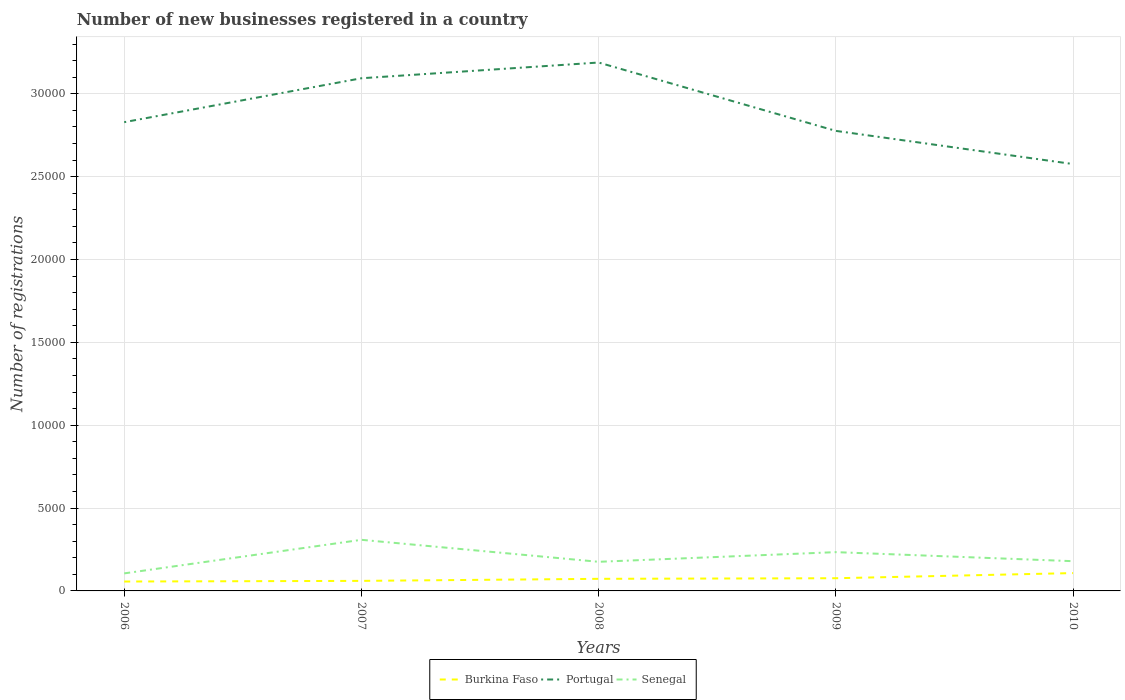Is the number of lines equal to the number of legend labels?
Provide a short and direct response. Yes. Across all years, what is the maximum number of new businesses registered in Portugal?
Provide a succinct answer. 2.58e+04. What is the total number of new businesses registered in Senegal in the graph?
Keep it short and to the point. -2026. What is the difference between the highest and the second highest number of new businesses registered in Portugal?
Keep it short and to the point. 6126. What is the difference between the highest and the lowest number of new businesses registered in Portugal?
Offer a terse response. 2. How many lines are there?
Make the answer very short. 3. Are the values on the major ticks of Y-axis written in scientific E-notation?
Provide a short and direct response. No. Where does the legend appear in the graph?
Keep it short and to the point. Bottom center. How many legend labels are there?
Provide a short and direct response. 3. What is the title of the graph?
Ensure brevity in your answer.  Number of new businesses registered in a country. What is the label or title of the Y-axis?
Ensure brevity in your answer.  Number of registrations. What is the Number of registrations of Burkina Faso in 2006?
Offer a very short reply. 567. What is the Number of registrations of Portugal in 2006?
Provide a short and direct response. 2.83e+04. What is the Number of registrations in Senegal in 2006?
Offer a very short reply. 1058. What is the Number of registrations of Burkina Faso in 2007?
Ensure brevity in your answer.  606. What is the Number of registrations of Portugal in 2007?
Your answer should be compact. 3.09e+04. What is the Number of registrations in Senegal in 2007?
Ensure brevity in your answer.  3084. What is the Number of registrations in Burkina Faso in 2008?
Your answer should be very brief. 730. What is the Number of registrations in Portugal in 2008?
Provide a short and direct response. 3.19e+04. What is the Number of registrations in Senegal in 2008?
Your answer should be very brief. 1757. What is the Number of registrations in Burkina Faso in 2009?
Offer a very short reply. 766. What is the Number of registrations of Portugal in 2009?
Provide a short and direct response. 2.78e+04. What is the Number of registrations in Senegal in 2009?
Offer a very short reply. 2340. What is the Number of registrations of Burkina Faso in 2010?
Make the answer very short. 1076. What is the Number of registrations in Portugal in 2010?
Your answer should be compact. 2.58e+04. What is the Number of registrations of Senegal in 2010?
Ensure brevity in your answer.  1794. Across all years, what is the maximum Number of registrations in Burkina Faso?
Keep it short and to the point. 1076. Across all years, what is the maximum Number of registrations in Portugal?
Provide a short and direct response. 3.19e+04. Across all years, what is the maximum Number of registrations of Senegal?
Give a very brief answer. 3084. Across all years, what is the minimum Number of registrations of Burkina Faso?
Offer a terse response. 567. Across all years, what is the minimum Number of registrations in Portugal?
Offer a very short reply. 2.58e+04. Across all years, what is the minimum Number of registrations of Senegal?
Offer a very short reply. 1058. What is the total Number of registrations of Burkina Faso in the graph?
Keep it short and to the point. 3745. What is the total Number of registrations of Portugal in the graph?
Ensure brevity in your answer.  1.45e+05. What is the total Number of registrations in Senegal in the graph?
Your response must be concise. 1.00e+04. What is the difference between the Number of registrations of Burkina Faso in 2006 and that in 2007?
Your answer should be very brief. -39. What is the difference between the Number of registrations in Portugal in 2006 and that in 2007?
Provide a succinct answer. -2650. What is the difference between the Number of registrations of Senegal in 2006 and that in 2007?
Your response must be concise. -2026. What is the difference between the Number of registrations of Burkina Faso in 2006 and that in 2008?
Your answer should be very brief. -163. What is the difference between the Number of registrations in Portugal in 2006 and that in 2008?
Make the answer very short. -3599. What is the difference between the Number of registrations in Senegal in 2006 and that in 2008?
Provide a succinct answer. -699. What is the difference between the Number of registrations of Burkina Faso in 2006 and that in 2009?
Your response must be concise. -199. What is the difference between the Number of registrations in Portugal in 2006 and that in 2009?
Your answer should be compact. 525. What is the difference between the Number of registrations of Senegal in 2006 and that in 2009?
Keep it short and to the point. -1282. What is the difference between the Number of registrations in Burkina Faso in 2006 and that in 2010?
Offer a very short reply. -509. What is the difference between the Number of registrations in Portugal in 2006 and that in 2010?
Your response must be concise. 2527. What is the difference between the Number of registrations in Senegal in 2006 and that in 2010?
Make the answer very short. -736. What is the difference between the Number of registrations in Burkina Faso in 2007 and that in 2008?
Your answer should be very brief. -124. What is the difference between the Number of registrations in Portugal in 2007 and that in 2008?
Make the answer very short. -949. What is the difference between the Number of registrations in Senegal in 2007 and that in 2008?
Your answer should be compact. 1327. What is the difference between the Number of registrations of Burkina Faso in 2007 and that in 2009?
Make the answer very short. -160. What is the difference between the Number of registrations in Portugal in 2007 and that in 2009?
Keep it short and to the point. 3175. What is the difference between the Number of registrations of Senegal in 2007 and that in 2009?
Give a very brief answer. 744. What is the difference between the Number of registrations of Burkina Faso in 2007 and that in 2010?
Give a very brief answer. -470. What is the difference between the Number of registrations in Portugal in 2007 and that in 2010?
Your response must be concise. 5177. What is the difference between the Number of registrations in Senegal in 2007 and that in 2010?
Keep it short and to the point. 1290. What is the difference between the Number of registrations in Burkina Faso in 2008 and that in 2009?
Offer a very short reply. -36. What is the difference between the Number of registrations in Portugal in 2008 and that in 2009?
Your answer should be compact. 4124. What is the difference between the Number of registrations of Senegal in 2008 and that in 2009?
Provide a succinct answer. -583. What is the difference between the Number of registrations in Burkina Faso in 2008 and that in 2010?
Your response must be concise. -346. What is the difference between the Number of registrations in Portugal in 2008 and that in 2010?
Ensure brevity in your answer.  6126. What is the difference between the Number of registrations of Senegal in 2008 and that in 2010?
Provide a succinct answer. -37. What is the difference between the Number of registrations in Burkina Faso in 2009 and that in 2010?
Your answer should be very brief. -310. What is the difference between the Number of registrations of Portugal in 2009 and that in 2010?
Make the answer very short. 2002. What is the difference between the Number of registrations in Senegal in 2009 and that in 2010?
Your answer should be compact. 546. What is the difference between the Number of registrations of Burkina Faso in 2006 and the Number of registrations of Portugal in 2007?
Keep it short and to the point. -3.04e+04. What is the difference between the Number of registrations in Burkina Faso in 2006 and the Number of registrations in Senegal in 2007?
Provide a short and direct response. -2517. What is the difference between the Number of registrations of Portugal in 2006 and the Number of registrations of Senegal in 2007?
Give a very brief answer. 2.52e+04. What is the difference between the Number of registrations of Burkina Faso in 2006 and the Number of registrations of Portugal in 2008?
Keep it short and to the point. -3.13e+04. What is the difference between the Number of registrations of Burkina Faso in 2006 and the Number of registrations of Senegal in 2008?
Give a very brief answer. -1190. What is the difference between the Number of registrations in Portugal in 2006 and the Number of registrations in Senegal in 2008?
Your answer should be very brief. 2.65e+04. What is the difference between the Number of registrations of Burkina Faso in 2006 and the Number of registrations of Portugal in 2009?
Make the answer very short. -2.72e+04. What is the difference between the Number of registrations of Burkina Faso in 2006 and the Number of registrations of Senegal in 2009?
Keep it short and to the point. -1773. What is the difference between the Number of registrations of Portugal in 2006 and the Number of registrations of Senegal in 2009?
Provide a short and direct response. 2.59e+04. What is the difference between the Number of registrations in Burkina Faso in 2006 and the Number of registrations in Portugal in 2010?
Your answer should be very brief. -2.52e+04. What is the difference between the Number of registrations of Burkina Faso in 2006 and the Number of registrations of Senegal in 2010?
Ensure brevity in your answer.  -1227. What is the difference between the Number of registrations in Portugal in 2006 and the Number of registrations in Senegal in 2010?
Offer a very short reply. 2.65e+04. What is the difference between the Number of registrations of Burkina Faso in 2007 and the Number of registrations of Portugal in 2008?
Keep it short and to the point. -3.13e+04. What is the difference between the Number of registrations in Burkina Faso in 2007 and the Number of registrations in Senegal in 2008?
Give a very brief answer. -1151. What is the difference between the Number of registrations of Portugal in 2007 and the Number of registrations of Senegal in 2008?
Offer a terse response. 2.92e+04. What is the difference between the Number of registrations of Burkina Faso in 2007 and the Number of registrations of Portugal in 2009?
Make the answer very short. -2.72e+04. What is the difference between the Number of registrations of Burkina Faso in 2007 and the Number of registrations of Senegal in 2009?
Offer a terse response. -1734. What is the difference between the Number of registrations of Portugal in 2007 and the Number of registrations of Senegal in 2009?
Your answer should be compact. 2.86e+04. What is the difference between the Number of registrations of Burkina Faso in 2007 and the Number of registrations of Portugal in 2010?
Ensure brevity in your answer.  -2.52e+04. What is the difference between the Number of registrations of Burkina Faso in 2007 and the Number of registrations of Senegal in 2010?
Offer a terse response. -1188. What is the difference between the Number of registrations of Portugal in 2007 and the Number of registrations of Senegal in 2010?
Provide a short and direct response. 2.91e+04. What is the difference between the Number of registrations of Burkina Faso in 2008 and the Number of registrations of Portugal in 2009?
Your answer should be compact. -2.70e+04. What is the difference between the Number of registrations in Burkina Faso in 2008 and the Number of registrations in Senegal in 2009?
Your response must be concise. -1610. What is the difference between the Number of registrations of Portugal in 2008 and the Number of registrations of Senegal in 2009?
Your response must be concise. 2.95e+04. What is the difference between the Number of registrations in Burkina Faso in 2008 and the Number of registrations in Portugal in 2010?
Your response must be concise. -2.50e+04. What is the difference between the Number of registrations in Burkina Faso in 2008 and the Number of registrations in Senegal in 2010?
Offer a very short reply. -1064. What is the difference between the Number of registrations in Portugal in 2008 and the Number of registrations in Senegal in 2010?
Keep it short and to the point. 3.01e+04. What is the difference between the Number of registrations of Burkina Faso in 2009 and the Number of registrations of Portugal in 2010?
Keep it short and to the point. -2.50e+04. What is the difference between the Number of registrations in Burkina Faso in 2009 and the Number of registrations in Senegal in 2010?
Your answer should be compact. -1028. What is the difference between the Number of registrations in Portugal in 2009 and the Number of registrations in Senegal in 2010?
Your answer should be very brief. 2.60e+04. What is the average Number of registrations of Burkina Faso per year?
Ensure brevity in your answer.  749. What is the average Number of registrations in Portugal per year?
Your answer should be very brief. 2.89e+04. What is the average Number of registrations of Senegal per year?
Make the answer very short. 2006.6. In the year 2006, what is the difference between the Number of registrations of Burkina Faso and Number of registrations of Portugal?
Your response must be concise. -2.77e+04. In the year 2006, what is the difference between the Number of registrations in Burkina Faso and Number of registrations in Senegal?
Ensure brevity in your answer.  -491. In the year 2006, what is the difference between the Number of registrations of Portugal and Number of registrations of Senegal?
Your response must be concise. 2.72e+04. In the year 2007, what is the difference between the Number of registrations of Burkina Faso and Number of registrations of Portugal?
Provide a short and direct response. -3.03e+04. In the year 2007, what is the difference between the Number of registrations in Burkina Faso and Number of registrations in Senegal?
Your response must be concise. -2478. In the year 2007, what is the difference between the Number of registrations in Portugal and Number of registrations in Senegal?
Your answer should be compact. 2.78e+04. In the year 2008, what is the difference between the Number of registrations in Burkina Faso and Number of registrations in Portugal?
Your answer should be compact. -3.12e+04. In the year 2008, what is the difference between the Number of registrations of Burkina Faso and Number of registrations of Senegal?
Make the answer very short. -1027. In the year 2008, what is the difference between the Number of registrations in Portugal and Number of registrations in Senegal?
Your response must be concise. 3.01e+04. In the year 2009, what is the difference between the Number of registrations of Burkina Faso and Number of registrations of Portugal?
Your response must be concise. -2.70e+04. In the year 2009, what is the difference between the Number of registrations in Burkina Faso and Number of registrations in Senegal?
Offer a very short reply. -1574. In the year 2009, what is the difference between the Number of registrations of Portugal and Number of registrations of Senegal?
Your answer should be very brief. 2.54e+04. In the year 2010, what is the difference between the Number of registrations of Burkina Faso and Number of registrations of Portugal?
Your answer should be very brief. -2.47e+04. In the year 2010, what is the difference between the Number of registrations in Burkina Faso and Number of registrations in Senegal?
Provide a succinct answer. -718. In the year 2010, what is the difference between the Number of registrations in Portugal and Number of registrations in Senegal?
Your response must be concise. 2.40e+04. What is the ratio of the Number of registrations in Burkina Faso in 2006 to that in 2007?
Provide a short and direct response. 0.94. What is the ratio of the Number of registrations of Portugal in 2006 to that in 2007?
Offer a terse response. 0.91. What is the ratio of the Number of registrations of Senegal in 2006 to that in 2007?
Offer a terse response. 0.34. What is the ratio of the Number of registrations of Burkina Faso in 2006 to that in 2008?
Ensure brevity in your answer.  0.78. What is the ratio of the Number of registrations of Portugal in 2006 to that in 2008?
Provide a short and direct response. 0.89. What is the ratio of the Number of registrations in Senegal in 2006 to that in 2008?
Your response must be concise. 0.6. What is the ratio of the Number of registrations in Burkina Faso in 2006 to that in 2009?
Provide a short and direct response. 0.74. What is the ratio of the Number of registrations in Portugal in 2006 to that in 2009?
Provide a succinct answer. 1.02. What is the ratio of the Number of registrations of Senegal in 2006 to that in 2009?
Your response must be concise. 0.45. What is the ratio of the Number of registrations in Burkina Faso in 2006 to that in 2010?
Offer a very short reply. 0.53. What is the ratio of the Number of registrations of Portugal in 2006 to that in 2010?
Ensure brevity in your answer.  1.1. What is the ratio of the Number of registrations of Senegal in 2006 to that in 2010?
Provide a succinct answer. 0.59. What is the ratio of the Number of registrations in Burkina Faso in 2007 to that in 2008?
Give a very brief answer. 0.83. What is the ratio of the Number of registrations of Portugal in 2007 to that in 2008?
Your answer should be compact. 0.97. What is the ratio of the Number of registrations of Senegal in 2007 to that in 2008?
Provide a short and direct response. 1.76. What is the ratio of the Number of registrations of Burkina Faso in 2007 to that in 2009?
Make the answer very short. 0.79. What is the ratio of the Number of registrations in Portugal in 2007 to that in 2009?
Your answer should be compact. 1.11. What is the ratio of the Number of registrations in Senegal in 2007 to that in 2009?
Your response must be concise. 1.32. What is the ratio of the Number of registrations in Burkina Faso in 2007 to that in 2010?
Your answer should be very brief. 0.56. What is the ratio of the Number of registrations of Portugal in 2007 to that in 2010?
Provide a succinct answer. 1.2. What is the ratio of the Number of registrations of Senegal in 2007 to that in 2010?
Make the answer very short. 1.72. What is the ratio of the Number of registrations of Burkina Faso in 2008 to that in 2009?
Give a very brief answer. 0.95. What is the ratio of the Number of registrations in Portugal in 2008 to that in 2009?
Provide a succinct answer. 1.15. What is the ratio of the Number of registrations in Senegal in 2008 to that in 2009?
Provide a short and direct response. 0.75. What is the ratio of the Number of registrations of Burkina Faso in 2008 to that in 2010?
Keep it short and to the point. 0.68. What is the ratio of the Number of registrations of Portugal in 2008 to that in 2010?
Provide a succinct answer. 1.24. What is the ratio of the Number of registrations of Senegal in 2008 to that in 2010?
Ensure brevity in your answer.  0.98. What is the ratio of the Number of registrations of Burkina Faso in 2009 to that in 2010?
Ensure brevity in your answer.  0.71. What is the ratio of the Number of registrations in Portugal in 2009 to that in 2010?
Offer a very short reply. 1.08. What is the ratio of the Number of registrations of Senegal in 2009 to that in 2010?
Ensure brevity in your answer.  1.3. What is the difference between the highest and the second highest Number of registrations in Burkina Faso?
Provide a succinct answer. 310. What is the difference between the highest and the second highest Number of registrations of Portugal?
Your response must be concise. 949. What is the difference between the highest and the second highest Number of registrations of Senegal?
Give a very brief answer. 744. What is the difference between the highest and the lowest Number of registrations in Burkina Faso?
Make the answer very short. 509. What is the difference between the highest and the lowest Number of registrations of Portugal?
Your answer should be very brief. 6126. What is the difference between the highest and the lowest Number of registrations of Senegal?
Offer a terse response. 2026. 